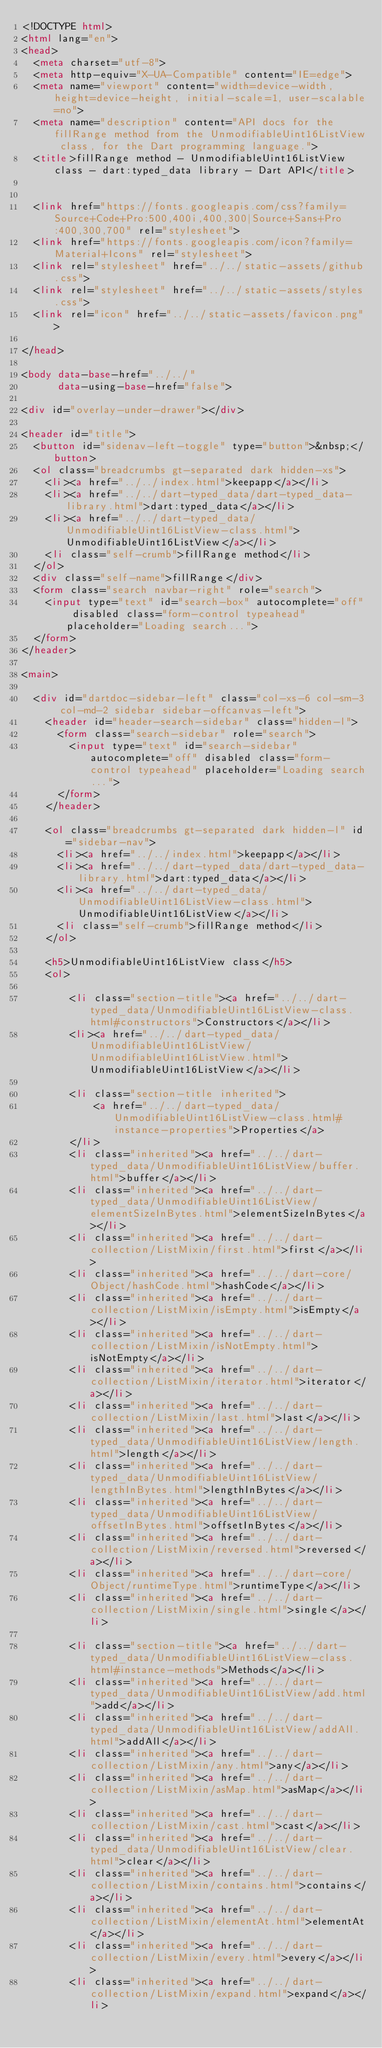<code> <loc_0><loc_0><loc_500><loc_500><_HTML_><!DOCTYPE html>
<html lang="en">
<head>
  <meta charset="utf-8">
  <meta http-equiv="X-UA-Compatible" content="IE=edge">
  <meta name="viewport" content="width=device-width, height=device-height, initial-scale=1, user-scalable=no">
  <meta name="description" content="API docs for the fillRange method from the UnmodifiableUint16ListView class, for the Dart programming language.">
  <title>fillRange method - UnmodifiableUint16ListView class - dart:typed_data library - Dart API</title>

  
  <link href="https://fonts.googleapis.com/css?family=Source+Code+Pro:500,400i,400,300|Source+Sans+Pro:400,300,700" rel="stylesheet">
  <link href="https://fonts.googleapis.com/icon?family=Material+Icons" rel="stylesheet">
  <link rel="stylesheet" href="../../static-assets/github.css">
  <link rel="stylesheet" href="../../static-assets/styles.css">
  <link rel="icon" href="../../static-assets/favicon.png">

</head>

<body data-base-href="../../"
      data-using-base-href="false">

<div id="overlay-under-drawer"></div>

<header id="title">
  <button id="sidenav-left-toggle" type="button">&nbsp;</button>
  <ol class="breadcrumbs gt-separated dark hidden-xs">
    <li><a href="../../index.html">keepapp</a></li>
    <li><a href="../../dart-typed_data/dart-typed_data-library.html">dart:typed_data</a></li>
    <li><a href="../../dart-typed_data/UnmodifiableUint16ListView-class.html">UnmodifiableUint16ListView</a></li>
    <li class="self-crumb">fillRange method</li>
  </ol>
  <div class="self-name">fillRange</div>
  <form class="search navbar-right" role="search">
    <input type="text" id="search-box" autocomplete="off" disabled class="form-control typeahead" placeholder="Loading search...">
  </form>
</header>

<main>

  <div id="dartdoc-sidebar-left" class="col-xs-6 col-sm-3 col-md-2 sidebar sidebar-offcanvas-left">
    <header id="header-search-sidebar" class="hidden-l">
      <form class="search-sidebar" role="search">
        <input type="text" id="search-sidebar" autocomplete="off" disabled class="form-control typeahead" placeholder="Loading search...">
      </form>
    </header>
    
    <ol class="breadcrumbs gt-separated dark hidden-l" id="sidebar-nav">
      <li><a href="../../index.html">keepapp</a></li>
      <li><a href="../../dart-typed_data/dart-typed_data-library.html">dart:typed_data</a></li>
      <li><a href="../../dart-typed_data/UnmodifiableUint16ListView-class.html">UnmodifiableUint16ListView</a></li>
      <li class="self-crumb">fillRange method</li>
    </ol>
    
    <h5>UnmodifiableUint16ListView class</h5>
    <ol>
    
        <li class="section-title"><a href="../../dart-typed_data/UnmodifiableUint16ListView-class.html#constructors">Constructors</a></li>
        <li><a href="../../dart-typed_data/UnmodifiableUint16ListView/UnmodifiableUint16ListView.html">UnmodifiableUint16ListView</a></li>
    
        <li class="section-title inherited">
            <a href="../../dart-typed_data/UnmodifiableUint16ListView-class.html#instance-properties">Properties</a>
        </li>
        <li class="inherited"><a href="../../dart-typed_data/UnmodifiableUint16ListView/buffer.html">buffer</a></li>
        <li class="inherited"><a href="../../dart-typed_data/UnmodifiableUint16ListView/elementSizeInBytes.html">elementSizeInBytes</a></li>
        <li class="inherited"><a href="../../dart-collection/ListMixin/first.html">first</a></li>
        <li class="inherited"><a href="../../dart-core/Object/hashCode.html">hashCode</a></li>
        <li class="inherited"><a href="../../dart-collection/ListMixin/isEmpty.html">isEmpty</a></li>
        <li class="inherited"><a href="../../dart-collection/ListMixin/isNotEmpty.html">isNotEmpty</a></li>
        <li class="inherited"><a href="../../dart-collection/ListMixin/iterator.html">iterator</a></li>
        <li class="inherited"><a href="../../dart-collection/ListMixin/last.html">last</a></li>
        <li class="inherited"><a href="../../dart-typed_data/UnmodifiableUint16ListView/length.html">length</a></li>
        <li class="inherited"><a href="../../dart-typed_data/UnmodifiableUint16ListView/lengthInBytes.html">lengthInBytes</a></li>
        <li class="inherited"><a href="../../dart-typed_data/UnmodifiableUint16ListView/offsetInBytes.html">offsetInBytes</a></li>
        <li class="inherited"><a href="../../dart-collection/ListMixin/reversed.html">reversed</a></li>
        <li class="inherited"><a href="../../dart-core/Object/runtimeType.html">runtimeType</a></li>
        <li class="inherited"><a href="../../dart-collection/ListMixin/single.html">single</a></li>
    
        <li class="section-title"><a href="../../dart-typed_data/UnmodifiableUint16ListView-class.html#instance-methods">Methods</a></li>
        <li class="inherited"><a href="../../dart-typed_data/UnmodifiableUint16ListView/add.html">add</a></li>
        <li class="inherited"><a href="../../dart-typed_data/UnmodifiableUint16ListView/addAll.html">addAll</a></li>
        <li class="inherited"><a href="../../dart-collection/ListMixin/any.html">any</a></li>
        <li class="inherited"><a href="../../dart-collection/ListMixin/asMap.html">asMap</a></li>
        <li class="inherited"><a href="../../dart-collection/ListMixin/cast.html">cast</a></li>
        <li class="inherited"><a href="../../dart-typed_data/UnmodifiableUint16ListView/clear.html">clear</a></li>
        <li class="inherited"><a href="../../dart-collection/ListMixin/contains.html">contains</a></li>
        <li class="inherited"><a href="../../dart-collection/ListMixin/elementAt.html">elementAt</a></li>
        <li class="inherited"><a href="../../dart-collection/ListMixin/every.html">every</a></li>
        <li class="inherited"><a href="../../dart-collection/ListMixin/expand.html">expand</a></li></code> 